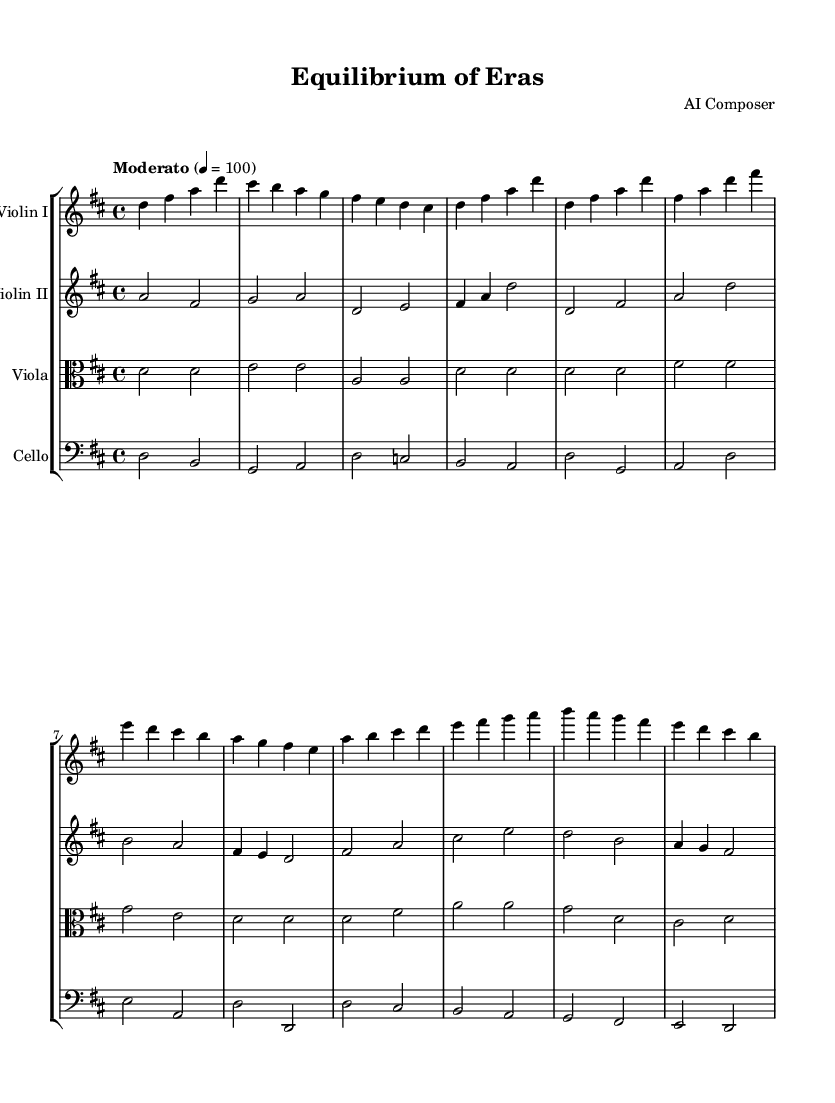What is the key signature of this music? The key signature is D major, which has two sharps: F# and C#.
Answer: D major What is the time signature of this music? The time signature is 4/4, indicating there are four beats per measure, and the quarter note gets one beat.
Answer: 4/4 What is the tempo marking of the piece? The tempo marking is "Moderato," indicating a moderate speed, typically around a half-note equaling 100 beats per minute.
Answer: Moderato How many primary themes are presented in the music? Two primary themes are presented, Theme A representing Tradition and Theme B representing Progress.
Answer: Two Which instrument has the lowest pitch range in this score? The cello is the lowest-pitched instrument in this score, playing in the bass clef.
Answer: Cello How does the second theme (Theme B) differ in rhythm from the first theme (Theme A)? Theme B has a faster rhythmic progression, expressing a sense of movement towards progress, contrasting with the more lyrical, flowing rhythm of Theme A.
Answer: Faster rhythm What are the dynamics indicated for the cello part? The dynamics indicated for the cello part are not explicitly shown, but the context of its playing suggests a supportive role in harmony and accompaniment, typically quiet to balance with higher instruments.
Answer: Not explicitly shown 